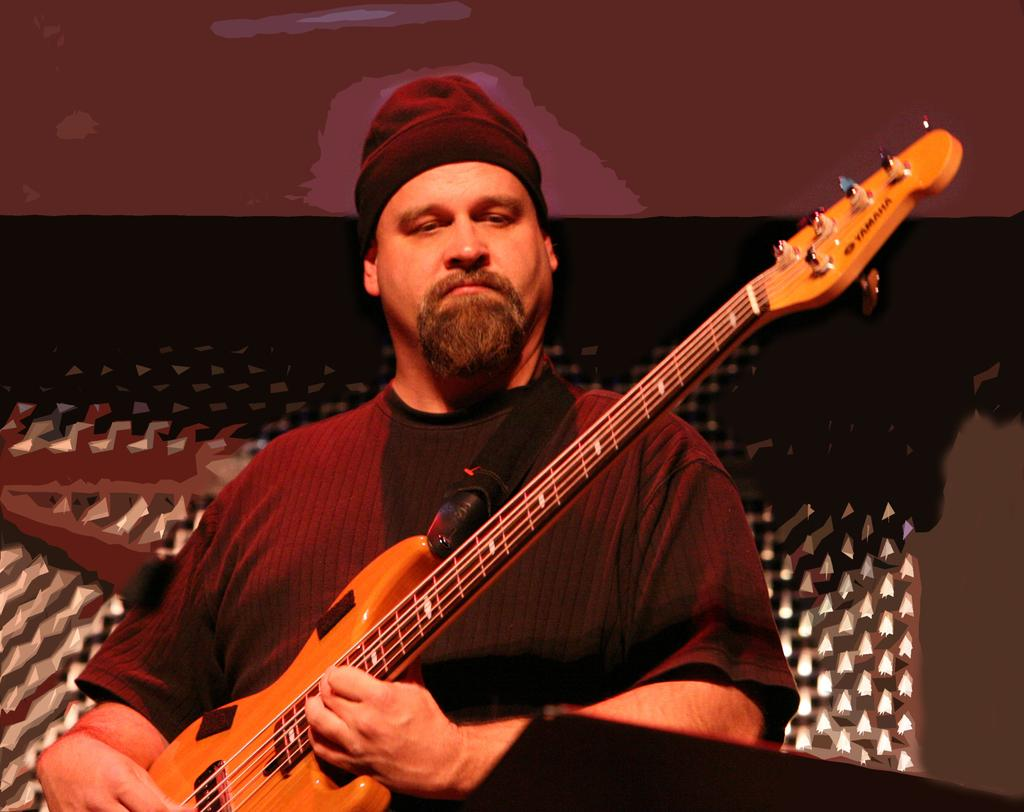What is the main subject of the image? There is a person in the image. What is the person holding in his hand? The person is holding a guitar in his hand. Can you see a duck in the image? No, there is no duck present in the image. Is there a receipt visible in the image? No, there is no receipt visible in the image. 